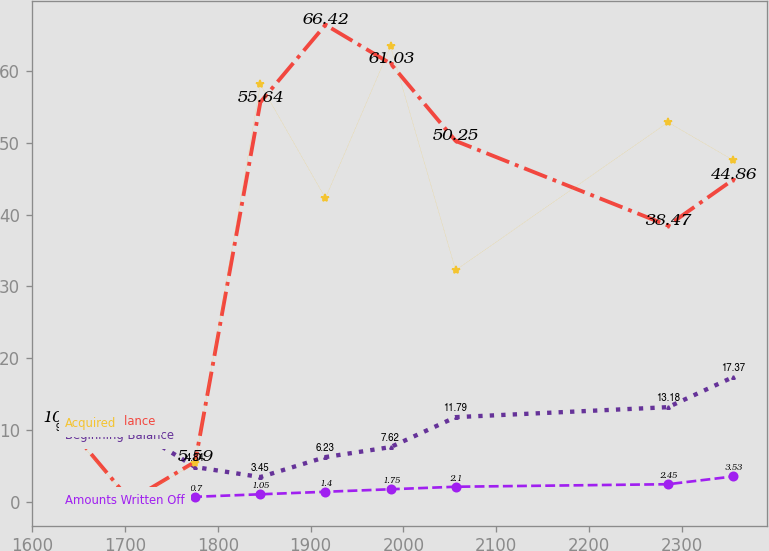<chart> <loc_0><loc_0><loc_500><loc_500><line_chart><ecel><fcel>Beginning Balance<fcel>Ending Balance<fcel>Amounts Written Off<fcel>Acquired<nl><fcel>1635.32<fcel>9.01<fcel>10.98<fcel>0<fcel>10.67<nl><fcel>1705.47<fcel>10.4<fcel>0.2<fcel>0.35<fcel>0.11<nl><fcel>1775.62<fcel>4.84<fcel>5.59<fcel>0.7<fcel>5.39<nl><fcel>1845.77<fcel>3.45<fcel>55.64<fcel>1.05<fcel>58.13<nl><fcel>1915.92<fcel>6.23<fcel>66.42<fcel>1.4<fcel>42.29<nl><fcel>1986.07<fcel>7.62<fcel>61.03<fcel>1.75<fcel>63.41<nl><fcel>2056.22<fcel>11.79<fcel>50.25<fcel>2.1<fcel>32.25<nl><fcel>2285.03<fcel>13.18<fcel>38.47<fcel>2.45<fcel>52.85<nl><fcel>2355.18<fcel>17.37<fcel>44.86<fcel>3.53<fcel>47.57<nl></chart> 